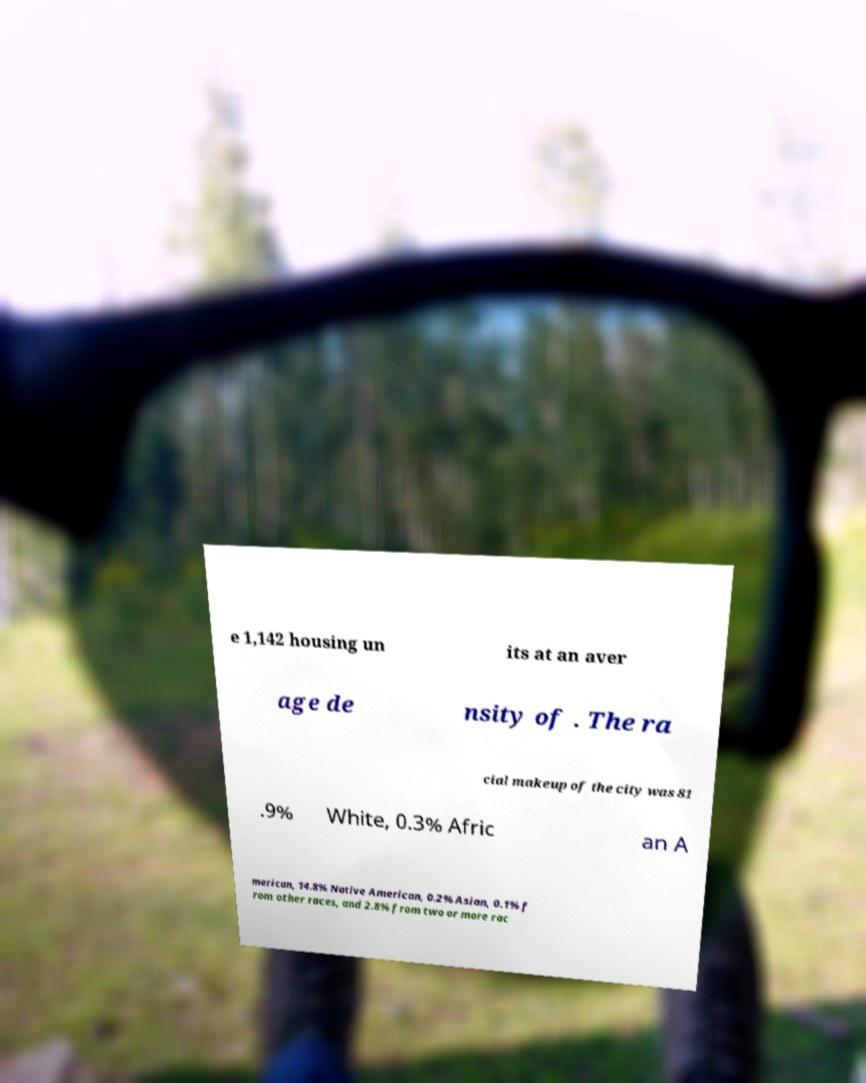There's text embedded in this image that I need extracted. Can you transcribe it verbatim? e 1,142 housing un its at an aver age de nsity of . The ra cial makeup of the city was 81 .9% White, 0.3% Afric an A merican, 14.8% Native American, 0.2% Asian, 0.1% f rom other races, and 2.8% from two or more rac 